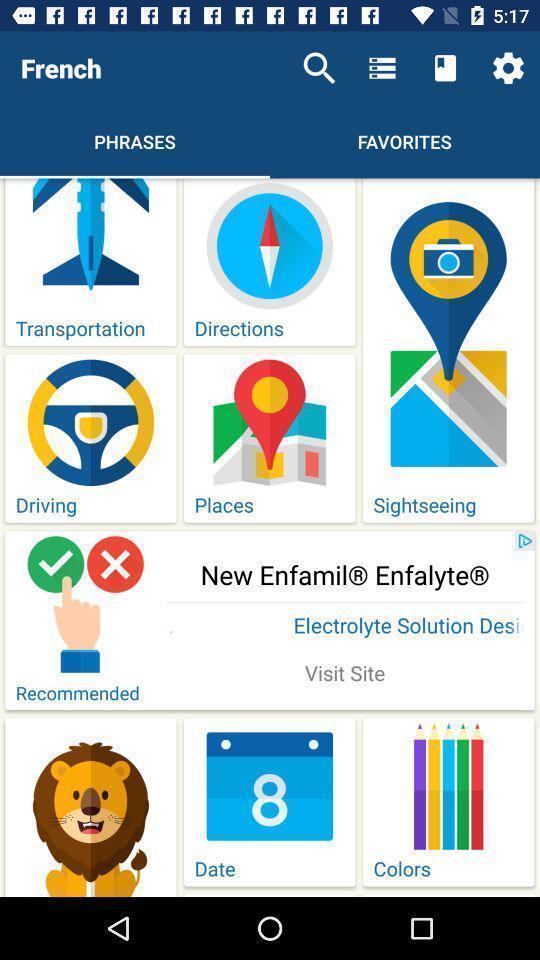Give me a summary of this screen capture. Page showing different collection of phrases of french. 